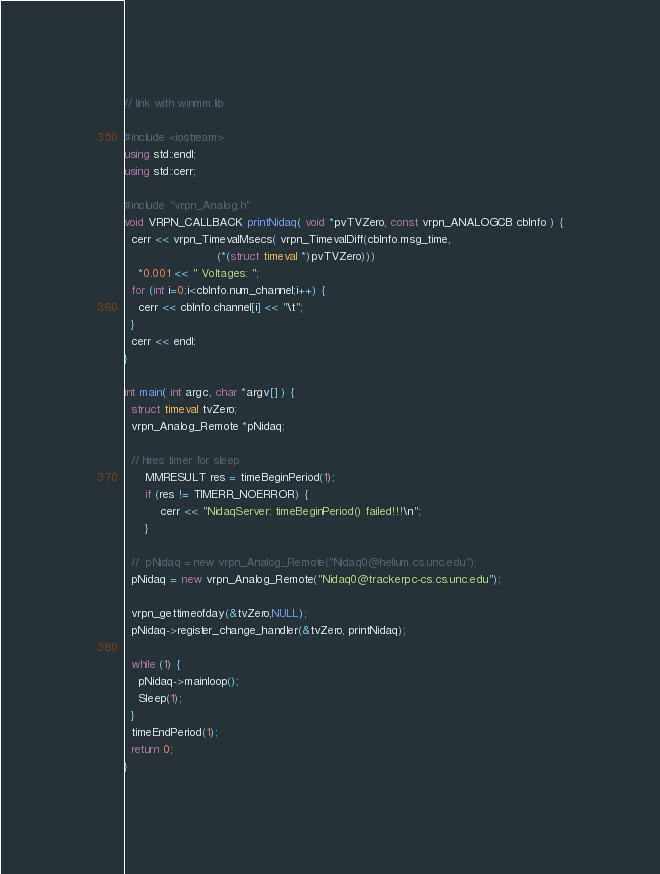<code> <loc_0><loc_0><loc_500><loc_500><_C++_>// link with winmm.lib

#include <iostream>
using std::endl;
using std::cerr;

#include "vrpn_Analog.h"
void VRPN_CALLBACK printNidaq( void *pvTVZero, const vrpn_ANALOGCB cbInfo ) {
  cerr << vrpn_TimevalMsecs( vrpn_TimevalDiff(cbInfo.msg_time,
					      (*(struct timeval *)pvTVZero)))
    *0.001 << " Voltages: ";
  for (int i=0;i<cbInfo.num_channel;i++) {
    cerr << cbInfo.channel[i] << "\t";
  }
  cerr << endl;
}

int main( int argc, char *argv[] ) {
  struct timeval tvZero;
  vrpn_Analog_Remote *pNidaq;

  // hires timer for sleep
	  MMRESULT res = timeBeginPeriod(1);
	  if (res != TIMERR_NOERROR) {
		  cerr << "NidaqServer: timeBeginPeriod() failed!!!\n";
	  }                       

  //  pNidaq = new vrpn_Analog_Remote("Nidaq0@helium.cs.unc.edu");
  pNidaq = new vrpn_Analog_Remote("Nidaq0@trackerpc-cs.cs.unc.edu");

  vrpn_gettimeofday(&tvZero,NULL);
  pNidaq->register_change_handler(&tvZero, printNidaq);
  
  while (1) {
    pNidaq->mainloop();
    Sleep(1);
  }
  timeEndPeriod(1);
  return 0;
}
</code> 